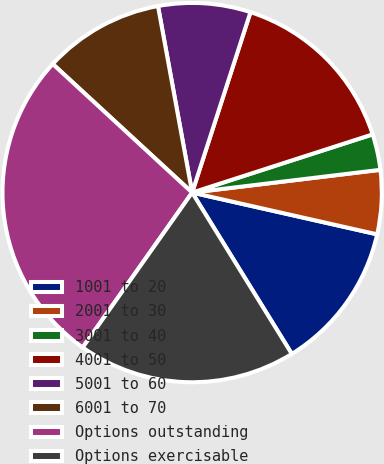Convert chart to OTSL. <chart><loc_0><loc_0><loc_500><loc_500><pie_chart><fcel>1001 to 20<fcel>2001 to 30<fcel>3001 to 40<fcel>4001 to 50<fcel>5001 to 60<fcel>6001 to 70<fcel>Options outstanding<fcel>Options exercisable<nl><fcel>12.66%<fcel>5.45%<fcel>3.05%<fcel>15.06%<fcel>7.86%<fcel>10.26%<fcel>27.07%<fcel>18.6%<nl></chart> 